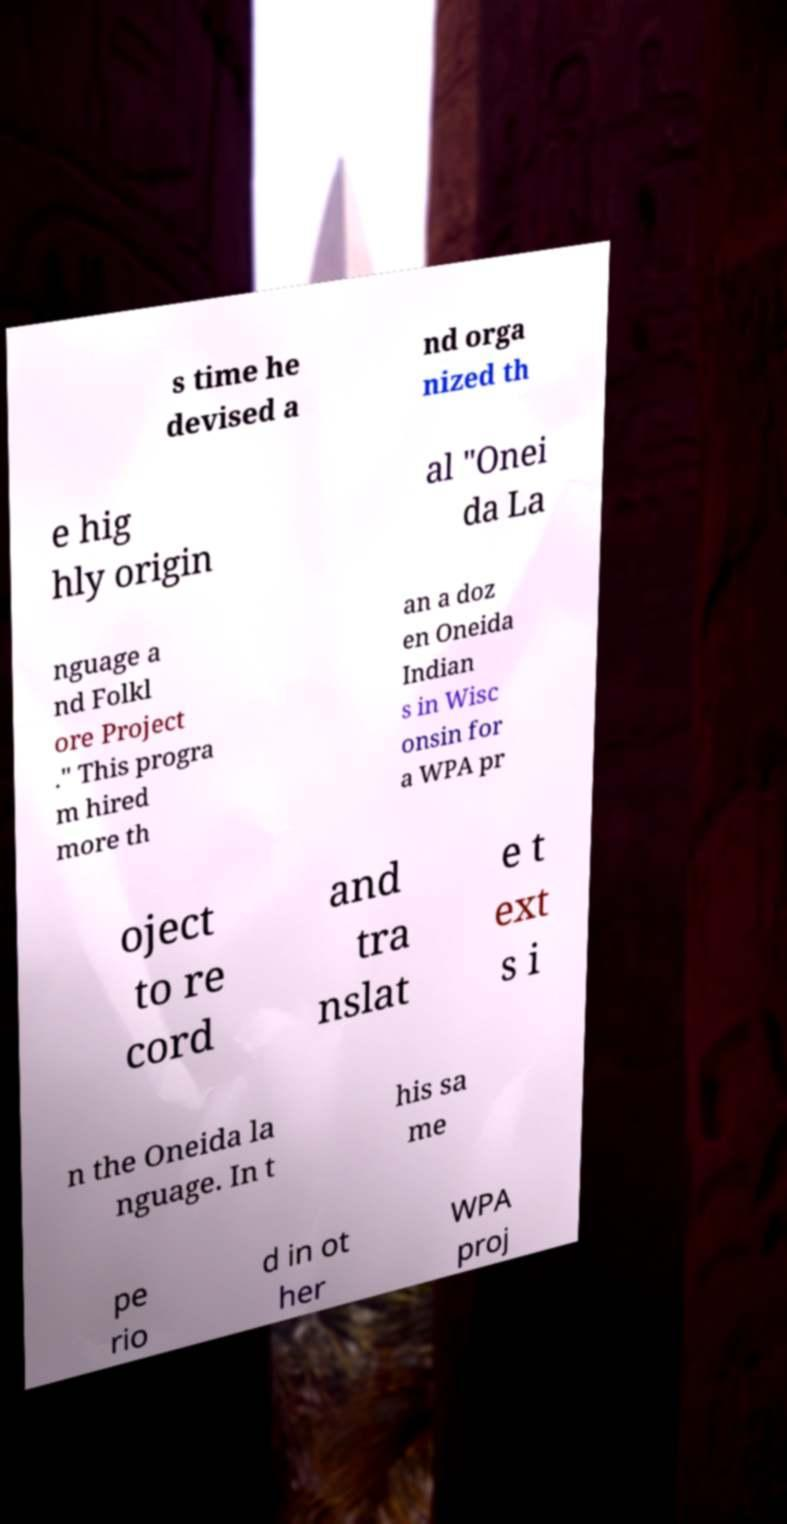For documentation purposes, I need the text within this image transcribed. Could you provide that? s time he devised a nd orga nized th e hig hly origin al "Onei da La nguage a nd Folkl ore Project ." This progra m hired more th an a doz en Oneida Indian s in Wisc onsin for a WPA pr oject to re cord and tra nslat e t ext s i n the Oneida la nguage. In t his sa me pe rio d in ot her WPA proj 